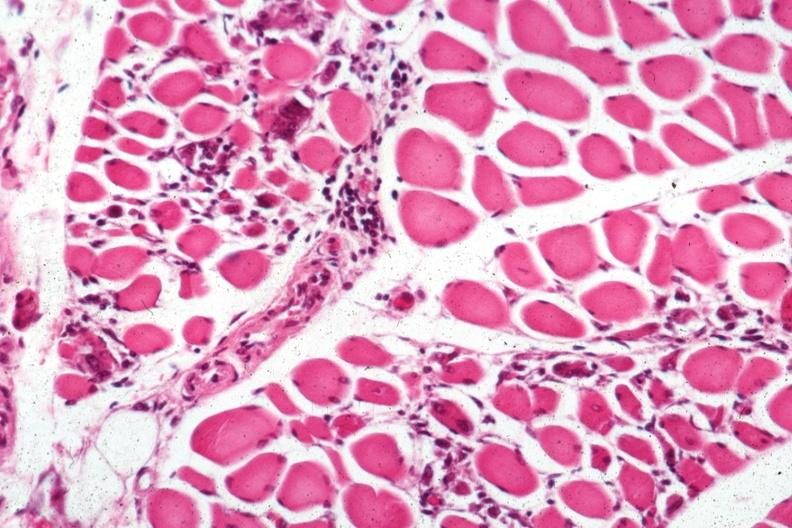s muscle present?
Answer the question using a single word or phrase. Yes 